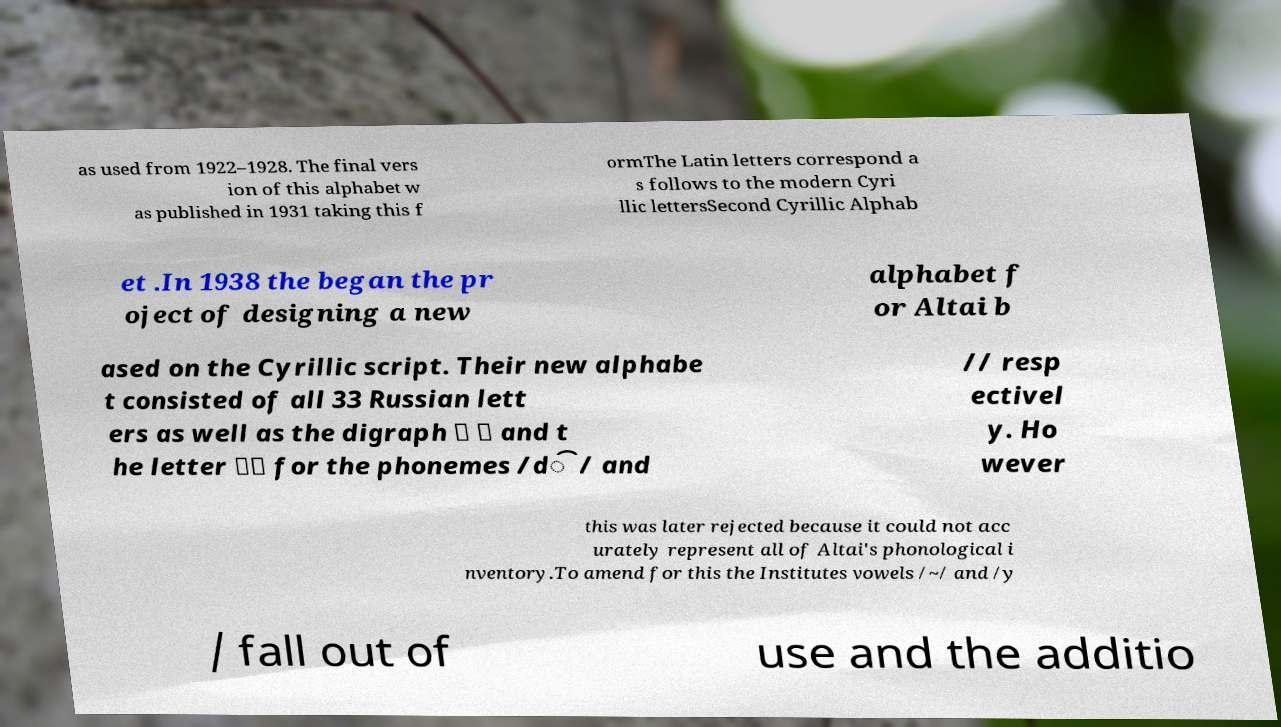I need the written content from this picture converted into text. Can you do that? as used from 1922–1928. The final vers ion of this alphabet w as published in 1931 taking this f ormThe Latin letters correspond a s follows to the modern Cyri llic lettersSecond Cyrillic Alphab et .In 1938 the began the pr oject of designing a new alphabet f or Altai b ased on the Cyrillic script. Their new alphabe t consisted of all 33 Russian lett ers as well as the digraph 〈 〉 and t he letter 〈〉 for the phonemes /d͡/ and // resp ectivel y. Ho wever this was later rejected because it could not acc urately represent all of Altai's phonological i nventory.To amend for this the Institutes vowels /~/ and /y / fall out of use and the additio 